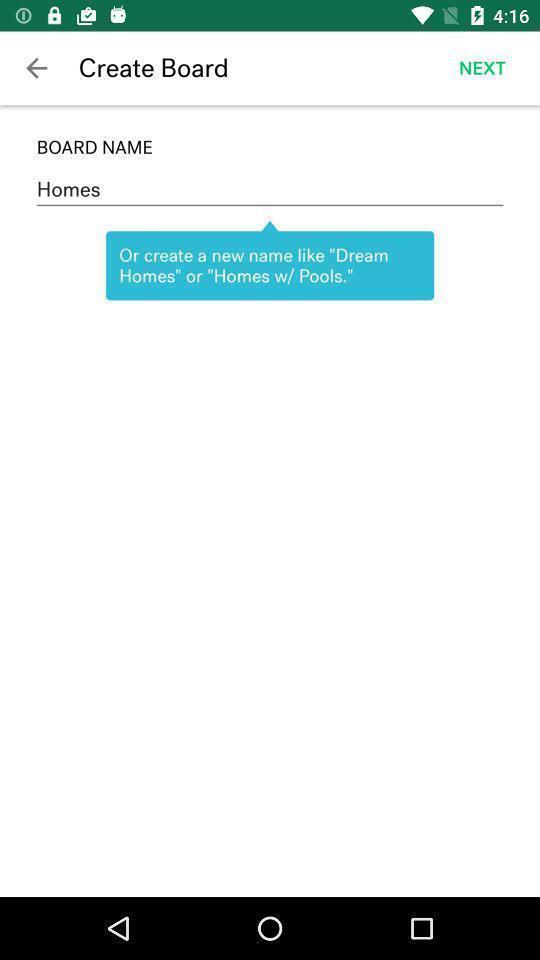Tell me what you see in this picture. Page displaying information about home finding application. 